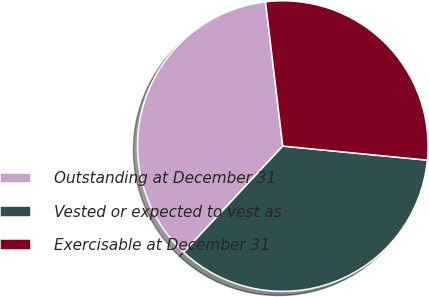<chart> <loc_0><loc_0><loc_500><loc_500><pie_chart><fcel>Outstanding at December 31<fcel>Vested or expected to vest as<fcel>Exercisable at December 31<nl><fcel>36.16%<fcel>35.4%<fcel>28.44%<nl></chart> 